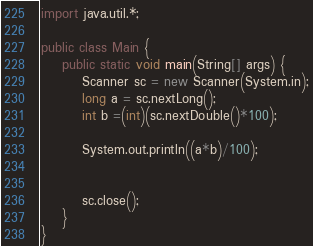<code> <loc_0><loc_0><loc_500><loc_500><_Java_>
import java.util.*;

public class Main {
	public static void main(String[] args) {
		Scanner sc = new Scanner(System.in);
		long a = sc.nextLong();
		int b =(int)(sc.nextDouble()*100);
				
		System.out.println((a*b)/100);
		
		
		sc.close();
	}
}
</code> 